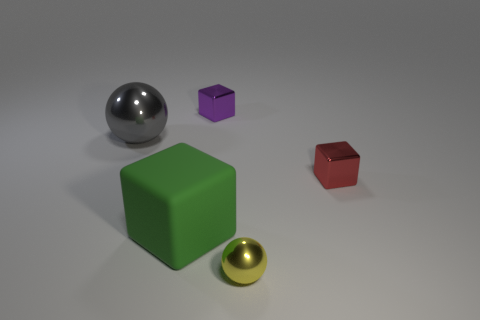Are there any other things that have the same material as the large cube?
Provide a short and direct response. No. Are there any red things of the same size as the purple block?
Your answer should be very brief. Yes. There is a gray sphere that is the same size as the green rubber object; what is its material?
Offer a very short reply. Metal. There is a purple metallic thing; is its size the same as the shiny sphere that is right of the big gray metallic ball?
Provide a short and direct response. Yes. What number of matte objects are big cyan spheres or tiny objects?
Provide a short and direct response. 0. What number of other gray things are the same shape as the matte object?
Offer a terse response. 0. There is a metallic thing on the left side of the tiny purple cube; is it the same size as the shiny object right of the tiny yellow metal object?
Give a very brief answer. No. The object that is in front of the large green rubber cube has what shape?
Keep it short and to the point. Sphere. There is a purple thing that is the same shape as the green matte thing; what is it made of?
Make the answer very short. Metal. There is a block right of the purple metal thing; does it have the same size as the yellow ball?
Ensure brevity in your answer.  Yes. 